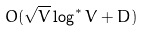Convert formula to latex. <formula><loc_0><loc_0><loc_500><loc_500>O ( \sqrt { V } \log ^ { * } V + D )</formula> 